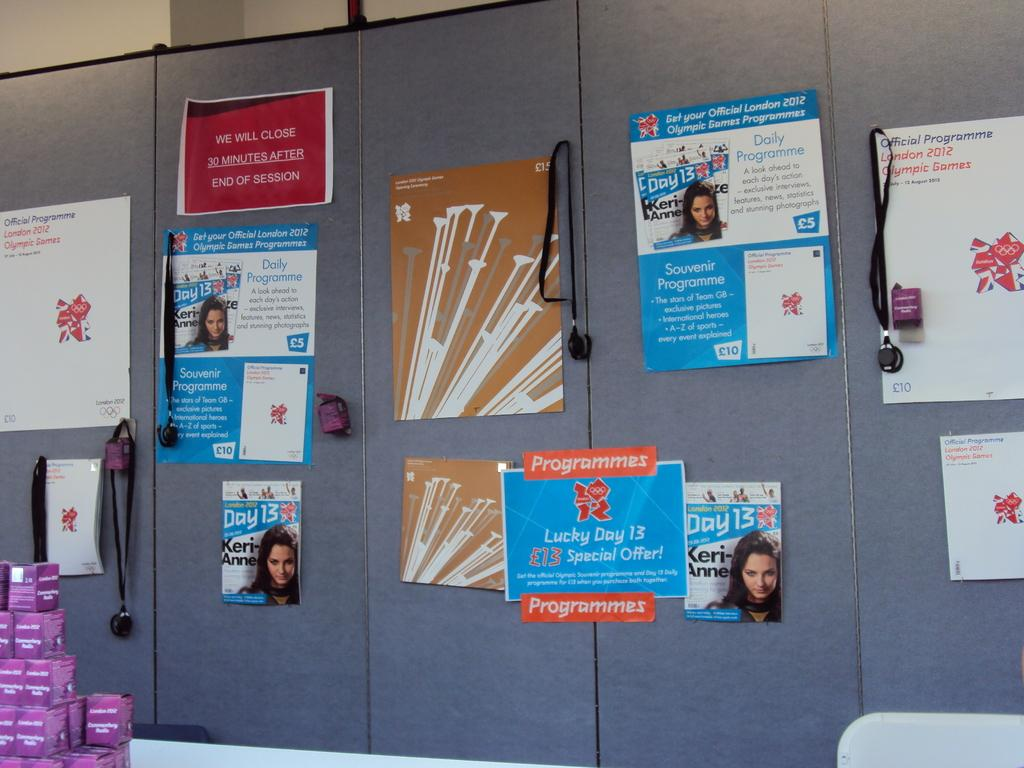<image>
Share a concise interpretation of the image provided. a work divider with posters including Day 13 London 2012 